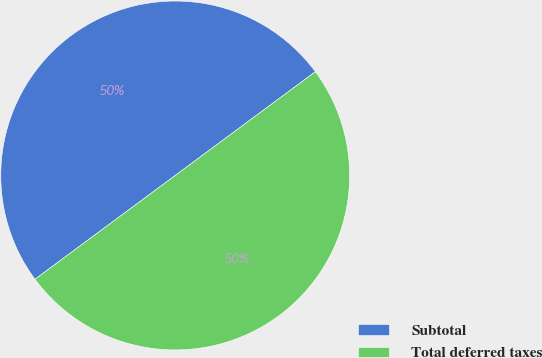<chart> <loc_0><loc_0><loc_500><loc_500><pie_chart><fcel>Subtotal<fcel>Total deferred taxes<nl><fcel>50.0%<fcel>50.0%<nl></chart> 